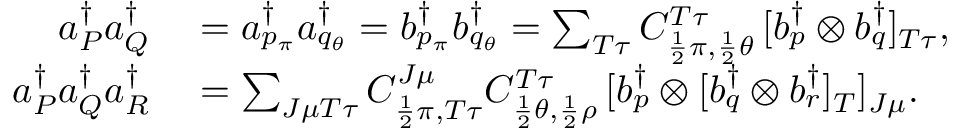<formula> <loc_0><loc_0><loc_500><loc_500>\begin{array} { r l } { a _ { P } ^ { \dagger } a _ { Q } ^ { \dagger } } & = a _ { p _ { \pi } } ^ { \dagger } a _ { q _ { \theta } } ^ { \dagger } = b _ { p _ { \pi } } ^ { \dagger } b _ { q _ { \theta } } ^ { \dagger } = \sum _ { T \tau } C _ { \frac { 1 } { 2 } \pi , \frac { 1 } { 2 } \theta } ^ { T \tau } \, [ b _ { p } ^ { \dagger } \otimes b _ { q } ^ { \dagger } ] _ { T \tau } , } \\ { a _ { P } ^ { \dagger } a _ { Q } ^ { \dagger } a _ { R } ^ { \dagger } } & = \sum _ { J \mu T \tau } C _ { \frac { 1 } { 2 } \pi , T \tau } ^ { J \mu } C _ { \frac { 1 } { 2 } \theta , \frac { 1 } { 2 } \rho } ^ { T \tau } \, [ b _ { p } ^ { \dagger } \otimes [ b _ { q } ^ { \dagger } \otimes b _ { r } ^ { \dagger } ] _ { T } ] _ { J \mu } . } \end{array}</formula> 